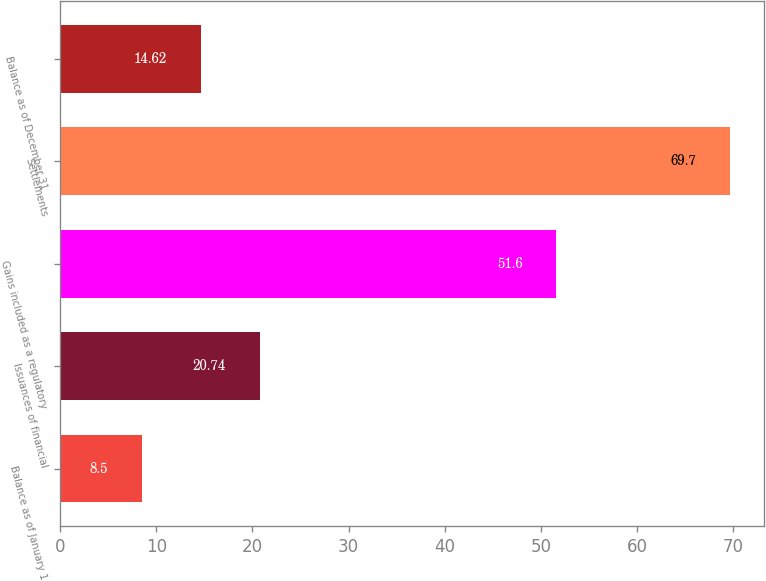Convert chart. <chart><loc_0><loc_0><loc_500><loc_500><bar_chart><fcel>Balance as of January 1<fcel>Issuances of financial<fcel>Gains included as a regulatory<fcel>Settlements<fcel>Balance as of December 31<nl><fcel>8.5<fcel>20.74<fcel>51.6<fcel>69.7<fcel>14.62<nl></chart> 